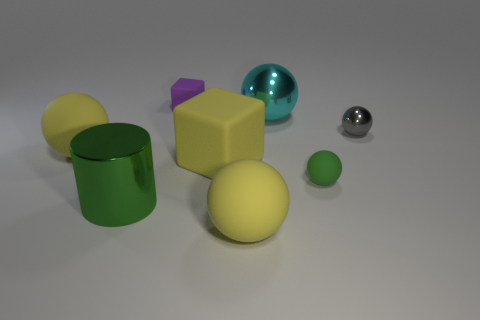Are there the same number of large metal objects behind the purple rubber block and matte balls?
Your response must be concise. No. Do the metallic object in front of the gray object and the matte block behind the large block have the same size?
Make the answer very short. No. What number of other things are the same size as the green shiny cylinder?
Make the answer very short. 4. There is a gray metal thing that is to the right of the large rubber sphere behind the green cylinder; are there any rubber objects behind it?
Your response must be concise. Yes. Are there any other things that have the same color as the metal cylinder?
Give a very brief answer. Yes. There is a thing that is behind the large cyan metallic thing; what is its size?
Your answer should be very brief. Small. How big is the purple matte cube that is on the right side of the large rubber sphere that is behind the big yellow ball in front of the green ball?
Your response must be concise. Small. The matte ball that is to the left of the yellow sphere that is in front of the large green shiny cylinder is what color?
Give a very brief answer. Yellow. What is the material of the other thing that is the same shape as the purple rubber object?
Provide a succinct answer. Rubber. There is a large rubber cube; are there any cyan shiny things right of it?
Your answer should be very brief. Yes. 